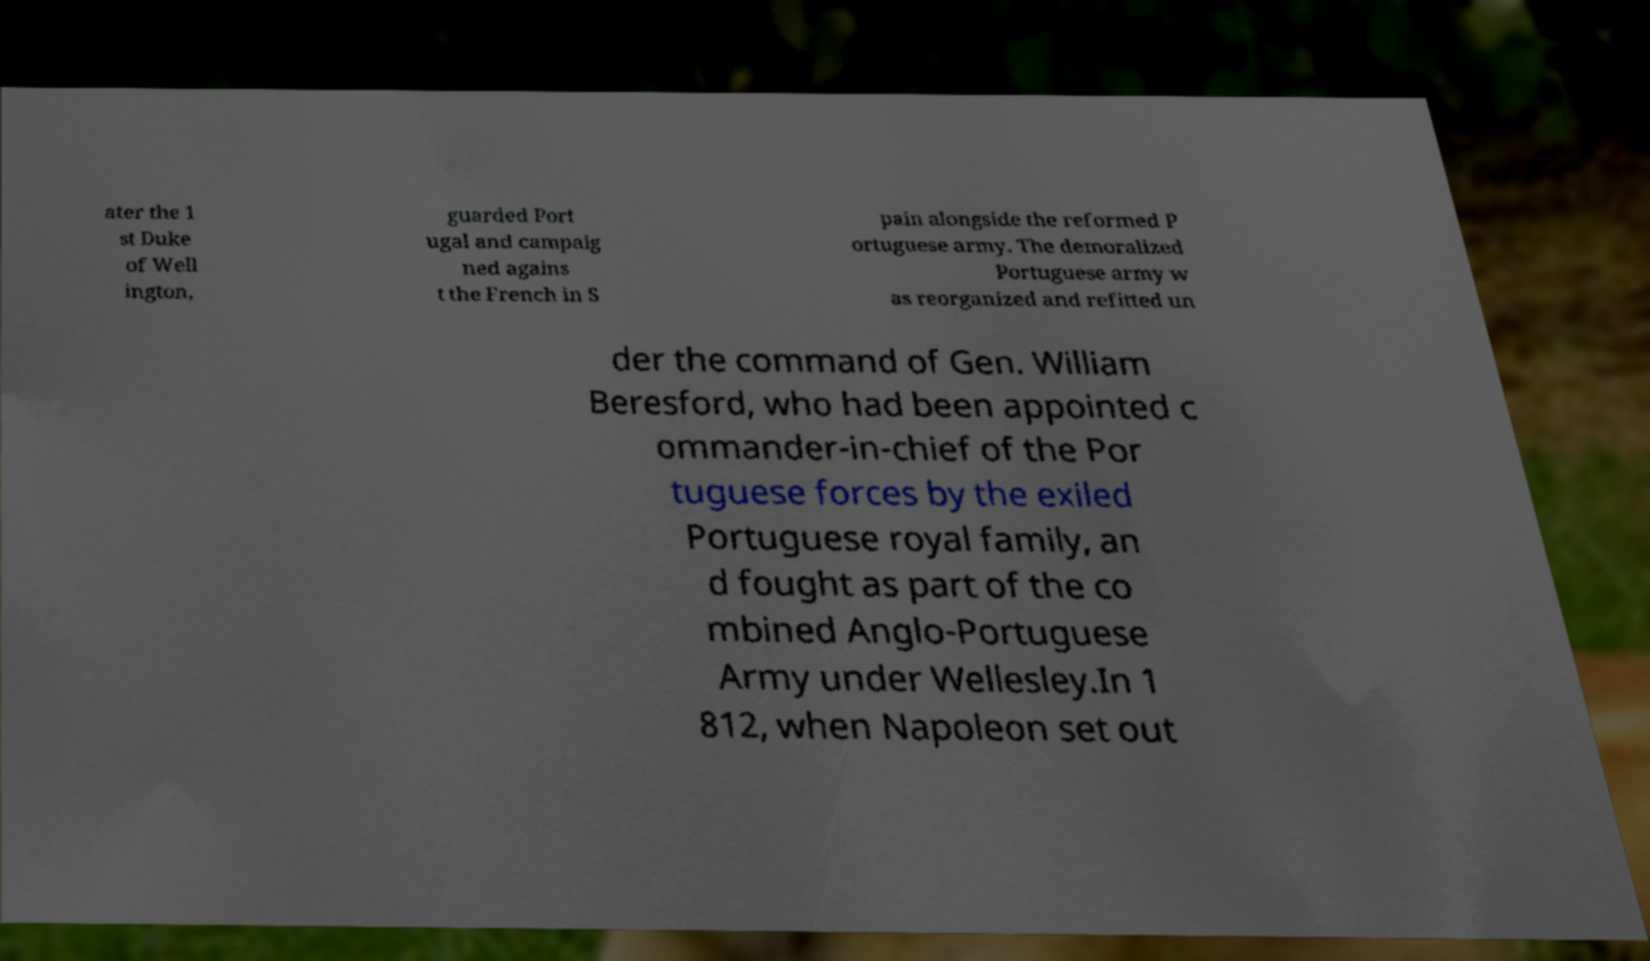Please identify and transcribe the text found in this image. ater the 1 st Duke of Well ington, guarded Port ugal and campaig ned agains t the French in S pain alongside the reformed P ortuguese army. The demoralized Portuguese army w as reorganized and refitted un der the command of Gen. William Beresford, who had been appointed c ommander-in-chief of the Por tuguese forces by the exiled Portuguese royal family, an d fought as part of the co mbined Anglo-Portuguese Army under Wellesley.In 1 812, when Napoleon set out 